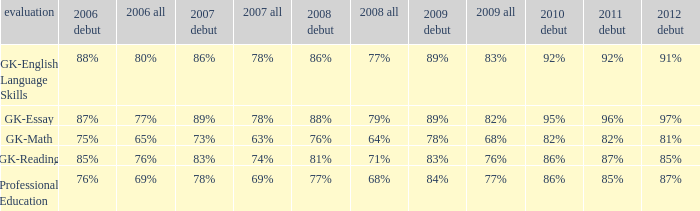What is the percentage for 2008 First time when in 2006 it was 85%? 81%. 